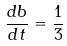Convert formula to latex. <formula><loc_0><loc_0><loc_500><loc_500>\frac { d b } { d t } = \frac { 1 } { 3 }</formula> 